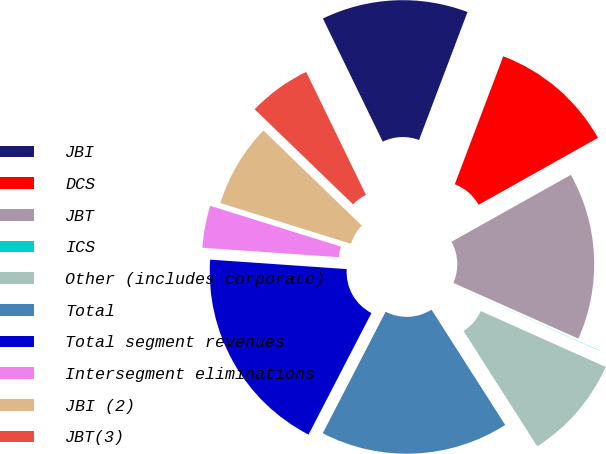Convert chart. <chart><loc_0><loc_0><loc_500><loc_500><pie_chart><fcel>JBI<fcel>DCS<fcel>JBT<fcel>ICS<fcel>Other (includes corporate)<fcel>Total<fcel>Total segment revenues<fcel>Intersegment eliminations<fcel>JBI (2)<fcel>JBT(3)<nl><fcel>12.96%<fcel>11.11%<fcel>14.8%<fcel>0.02%<fcel>9.26%<fcel>16.65%<fcel>18.5%<fcel>3.72%<fcel>7.41%<fcel>5.57%<nl></chart> 